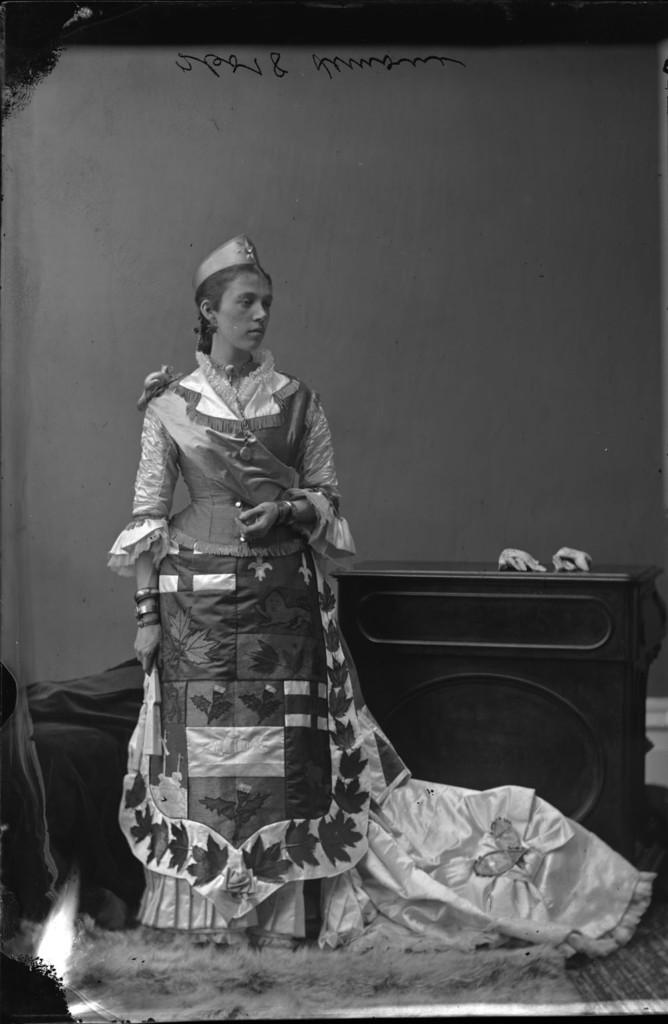Who is present in the image? There is a lady in the image. What can be seen in the background of the image? There is a stand and a wall in the background of the image. What type of question is the lady asking in the image? There is no indication in the image that the lady is asking a question. 